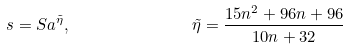Convert formula to latex. <formula><loc_0><loc_0><loc_500><loc_500>s = S a ^ { \tilde { \eta } } , \quad \, \quad \, \quad \, \quad \tilde { \eta } = \frac { 1 5 n ^ { 2 } + 9 6 n + 9 6 } { 1 0 n + 3 2 }</formula> 